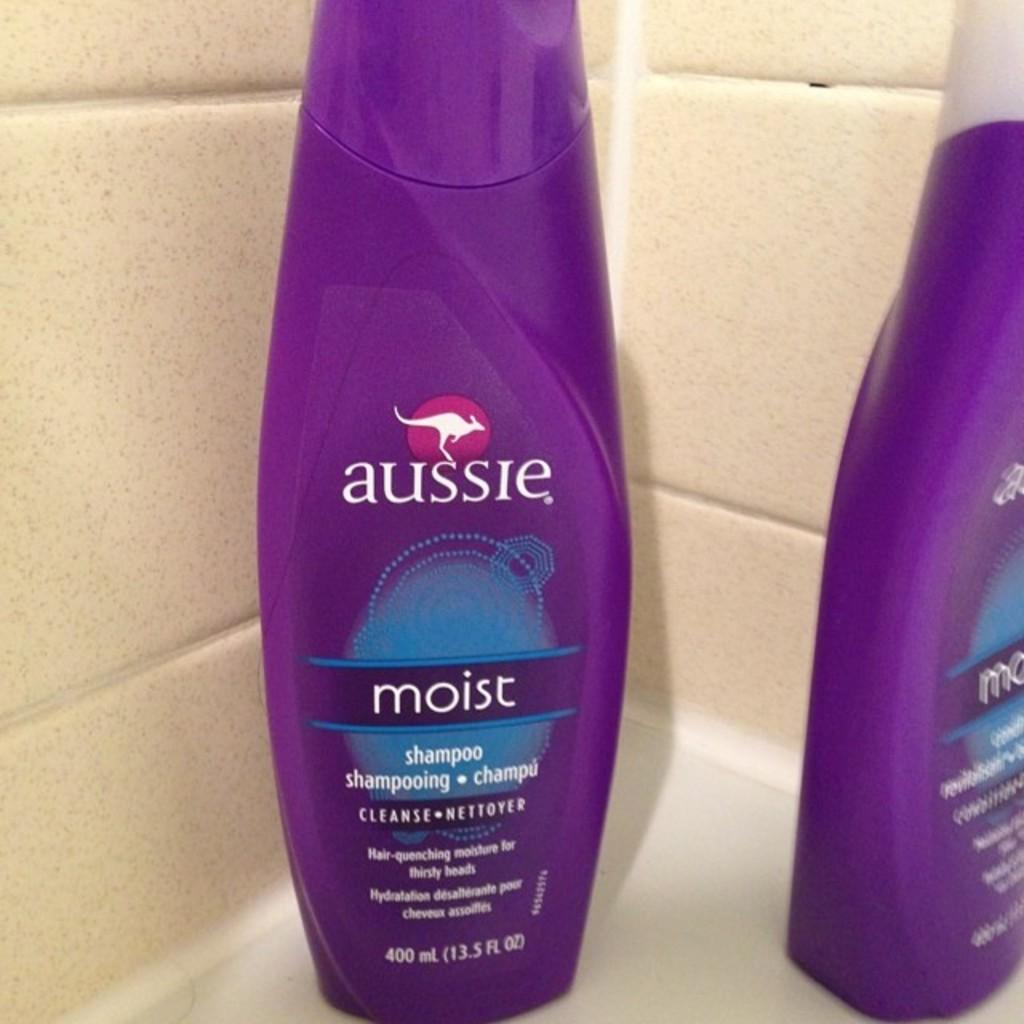<image>
Present a compact description of the photo's key features. Two bottles of aussie moist shampoo in a purple bottle 